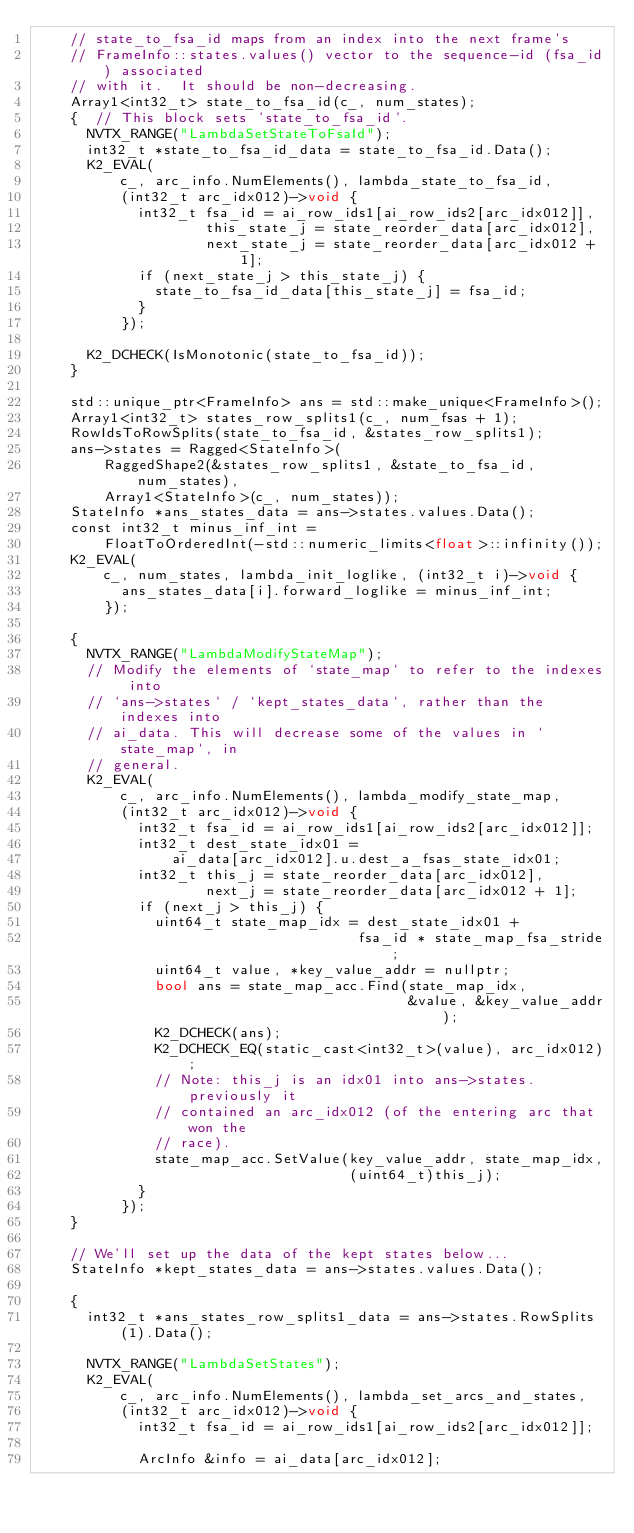Convert code to text. <code><loc_0><loc_0><loc_500><loc_500><_Cuda_>    // state_to_fsa_id maps from an index into the next frame's
    // FrameInfo::states.values() vector to the sequence-id (fsa_id) associated
    // with it.  It should be non-decreasing.
    Array1<int32_t> state_to_fsa_id(c_, num_states);
    {  // This block sets 'state_to_fsa_id'.
      NVTX_RANGE("LambdaSetStateToFsaId");
      int32_t *state_to_fsa_id_data = state_to_fsa_id.Data();
      K2_EVAL(
          c_, arc_info.NumElements(), lambda_state_to_fsa_id,
          (int32_t arc_idx012)->void {
            int32_t fsa_id = ai_row_ids1[ai_row_ids2[arc_idx012]],
                    this_state_j = state_reorder_data[arc_idx012],
                    next_state_j = state_reorder_data[arc_idx012 + 1];
            if (next_state_j > this_state_j) {
              state_to_fsa_id_data[this_state_j] = fsa_id;
            }
          });

      K2_DCHECK(IsMonotonic(state_to_fsa_id));
    }

    std::unique_ptr<FrameInfo> ans = std::make_unique<FrameInfo>();
    Array1<int32_t> states_row_splits1(c_, num_fsas + 1);
    RowIdsToRowSplits(state_to_fsa_id, &states_row_splits1);
    ans->states = Ragged<StateInfo>(
        RaggedShape2(&states_row_splits1, &state_to_fsa_id, num_states),
        Array1<StateInfo>(c_, num_states));
    StateInfo *ans_states_data = ans->states.values.Data();
    const int32_t minus_inf_int =
        FloatToOrderedInt(-std::numeric_limits<float>::infinity());
    K2_EVAL(
        c_, num_states, lambda_init_loglike, (int32_t i)->void {
          ans_states_data[i].forward_loglike = minus_inf_int;
        });

    {
      NVTX_RANGE("LambdaModifyStateMap");
      // Modify the elements of `state_map` to refer to the indexes into
      // `ans->states` / `kept_states_data`, rather than the indexes into
      // ai_data. This will decrease some of the values in `state_map`, in
      // general.
      K2_EVAL(
          c_, arc_info.NumElements(), lambda_modify_state_map,
          (int32_t arc_idx012)->void {
            int32_t fsa_id = ai_row_ids1[ai_row_ids2[arc_idx012]];
            int32_t dest_state_idx01 =
                ai_data[arc_idx012].u.dest_a_fsas_state_idx01;
            int32_t this_j = state_reorder_data[arc_idx012],
                    next_j = state_reorder_data[arc_idx012 + 1];
            if (next_j > this_j) {
              uint64_t state_map_idx = dest_state_idx01 +
                                      fsa_id * state_map_fsa_stride;
              uint64_t value, *key_value_addr = nullptr;
              bool ans = state_map_acc.Find(state_map_idx,
                                            &value, &key_value_addr);
              K2_DCHECK(ans);
              K2_DCHECK_EQ(static_cast<int32_t>(value), arc_idx012);
              // Note: this_j is an idx01 into ans->states.  previously it
              // contained an arc_idx012 (of the entering arc that won the
              // race).
              state_map_acc.SetValue(key_value_addr, state_map_idx,
                                     (uint64_t)this_j);
            }
          });
    }

    // We'll set up the data of the kept states below...
    StateInfo *kept_states_data = ans->states.values.Data();

    {
      int32_t *ans_states_row_splits1_data = ans->states.RowSplits(1).Data();

      NVTX_RANGE("LambdaSetStates");
      K2_EVAL(
          c_, arc_info.NumElements(), lambda_set_arcs_and_states,
          (int32_t arc_idx012)->void {
            int32_t fsa_id = ai_row_ids1[ai_row_ids2[arc_idx012]];

            ArcInfo &info = ai_data[arc_idx012];
</code> 